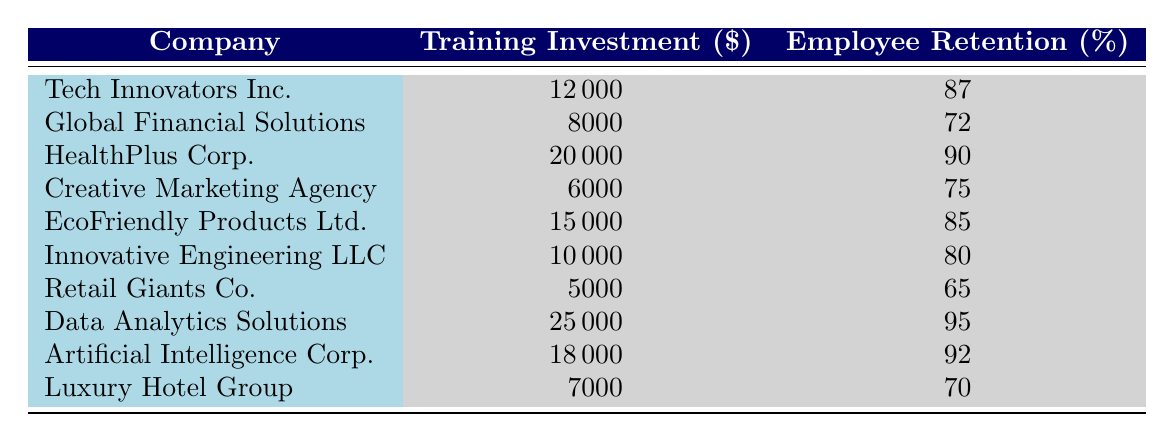What is the Employee Retention Rate for HealthPlus Corp.? The table lists HealthPlus Corp. with an Employee Retention Rate of 90%.
Answer: 90 Which company has the highest Training Investment? Comparing the Training Investment values, Data Analytics Solutions has the highest amount at 25000.
Answer: Data Analytics Solutions What is the average Training Investment among the companies listed? Adding all the Training Investment values: 12000 + 8000 + 20000 + 6000 + 15000 + 10000 + 5000 + 25000 + 18000 + 7000 = 112000. There are 10 companies, so the average is 112000 / 10 = 11200.
Answer: 11200 Is the Employee Retention Rate for EcoFriendly Products Ltd. greater than 80%? EcoFriendly Products Ltd. has an Employee Retention Rate of 85%, which is indeed greater than 80%.
Answer: Yes What is the difference between the highest and lowest Employee Retention Rates? The highest is 95% (Data Analytics Solutions) and the lowest is 65% (Retail Giants Co.), so the difference is 95 - 65 = 30.
Answer: 30 Which companies have a Training Investment greater than 15000? The companies with Training Investment above 15000 are HealthPlus Corp. (20000), Data Analytics Solutions (25000), and Artificial Intelligence Corp. (18000).
Answer: HealthPlus Corp., Data Analytics Solutions, Artificial Intelligence Corp What percentage of companies have an Employee Retention Rate above 80%? The companies with Retention Rates above 80% are Tech Innovators Inc. (87), HealthPlus Corp. (90), Data Analytics Solutions (95), and Artificial Intelligence Corp. (92). That's 4 out of 10 companies, giving a percentage of (4/10)*100 = 40%.
Answer: 40% Is there a direct correlation between Training Investment and Employee Retention Rates according to the table? Analyzing the data shows a general trend; as Training Investment increases, Employee Retention Rates also tend to be higher, suggesting a possible correlation. However, a more detailed statistical analysis would be required for definitive conclusions.
Answer: Yes 